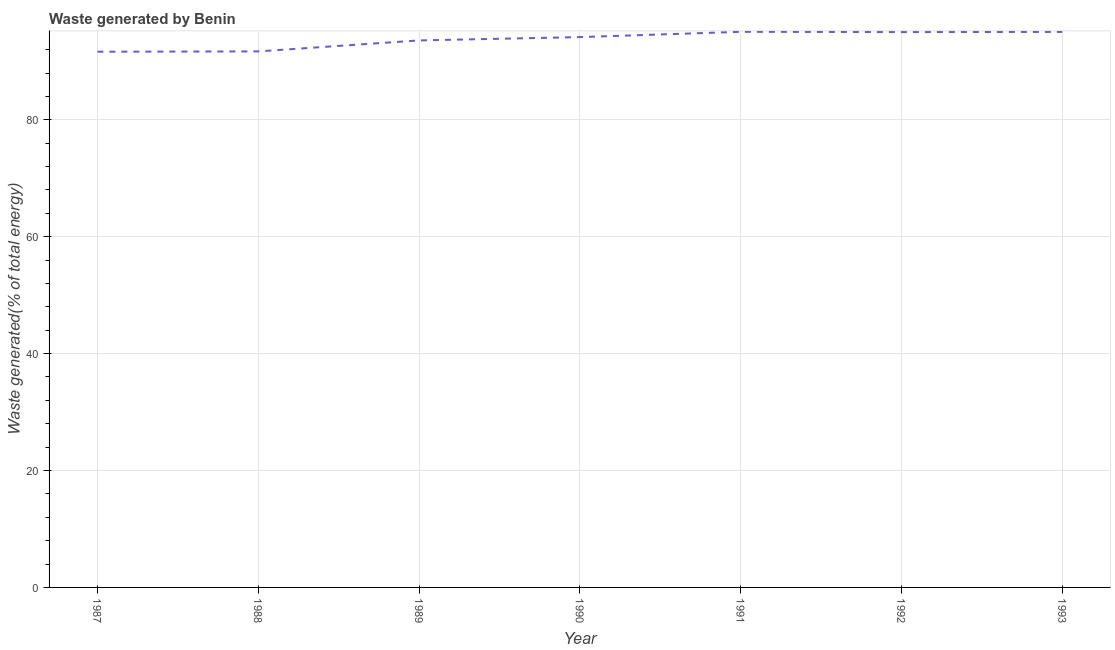What is the amount of waste generated in 1993?
Your response must be concise. 95.03. Across all years, what is the maximum amount of waste generated?
Provide a succinct answer. 95.05. Across all years, what is the minimum amount of waste generated?
Your answer should be very brief. 91.64. In which year was the amount of waste generated maximum?
Give a very brief answer. 1991. In which year was the amount of waste generated minimum?
Your answer should be compact. 1987. What is the sum of the amount of waste generated?
Make the answer very short. 656.15. What is the difference between the amount of waste generated in 1988 and 1990?
Keep it short and to the point. -2.45. What is the average amount of waste generated per year?
Provide a succinct answer. 93.74. What is the median amount of waste generated?
Ensure brevity in your answer.  94.15. Do a majority of the years between 1991 and 1988 (inclusive) have amount of waste generated greater than 24 %?
Provide a short and direct response. Yes. What is the ratio of the amount of waste generated in 1989 to that in 1993?
Give a very brief answer. 0.98. Is the amount of waste generated in 1988 less than that in 1989?
Ensure brevity in your answer.  Yes. Is the difference between the amount of waste generated in 1987 and 1992 greater than the difference between any two years?
Your answer should be very brief. No. What is the difference between the highest and the second highest amount of waste generated?
Offer a very short reply. 0.02. Is the sum of the amount of waste generated in 1990 and 1992 greater than the maximum amount of waste generated across all years?
Ensure brevity in your answer.  Yes. What is the difference between the highest and the lowest amount of waste generated?
Offer a terse response. 3.4. How many years are there in the graph?
Your answer should be compact. 7. What is the difference between two consecutive major ticks on the Y-axis?
Your answer should be compact. 20. What is the title of the graph?
Your answer should be compact. Waste generated by Benin. What is the label or title of the X-axis?
Offer a very short reply. Year. What is the label or title of the Y-axis?
Your answer should be very brief. Waste generated(% of total energy). What is the Waste generated(% of total energy) in 1987?
Provide a succinct answer. 91.64. What is the Waste generated(% of total energy) in 1988?
Provide a short and direct response. 91.7. What is the Waste generated(% of total energy) in 1989?
Give a very brief answer. 93.58. What is the Waste generated(% of total energy) in 1990?
Your response must be concise. 94.15. What is the Waste generated(% of total energy) of 1991?
Provide a succinct answer. 95.05. What is the Waste generated(% of total energy) in 1992?
Your answer should be very brief. 95. What is the Waste generated(% of total energy) in 1993?
Make the answer very short. 95.03. What is the difference between the Waste generated(% of total energy) in 1987 and 1988?
Keep it short and to the point. -0.05. What is the difference between the Waste generated(% of total energy) in 1987 and 1989?
Offer a terse response. -1.93. What is the difference between the Waste generated(% of total energy) in 1987 and 1990?
Offer a very short reply. -2.5. What is the difference between the Waste generated(% of total energy) in 1987 and 1991?
Offer a very short reply. -3.4. What is the difference between the Waste generated(% of total energy) in 1987 and 1992?
Keep it short and to the point. -3.36. What is the difference between the Waste generated(% of total energy) in 1987 and 1993?
Keep it short and to the point. -3.39. What is the difference between the Waste generated(% of total energy) in 1988 and 1989?
Your response must be concise. -1.88. What is the difference between the Waste generated(% of total energy) in 1988 and 1990?
Ensure brevity in your answer.  -2.45. What is the difference between the Waste generated(% of total energy) in 1988 and 1991?
Offer a very short reply. -3.35. What is the difference between the Waste generated(% of total energy) in 1988 and 1992?
Offer a very short reply. -3.31. What is the difference between the Waste generated(% of total energy) in 1988 and 1993?
Make the answer very short. -3.33. What is the difference between the Waste generated(% of total energy) in 1989 and 1990?
Offer a terse response. -0.57. What is the difference between the Waste generated(% of total energy) in 1989 and 1991?
Keep it short and to the point. -1.47. What is the difference between the Waste generated(% of total energy) in 1989 and 1992?
Give a very brief answer. -1.43. What is the difference between the Waste generated(% of total energy) in 1989 and 1993?
Your answer should be very brief. -1.46. What is the difference between the Waste generated(% of total energy) in 1990 and 1991?
Your response must be concise. -0.9. What is the difference between the Waste generated(% of total energy) in 1990 and 1992?
Give a very brief answer. -0.86. What is the difference between the Waste generated(% of total energy) in 1990 and 1993?
Your response must be concise. -0.89. What is the difference between the Waste generated(% of total energy) in 1991 and 1992?
Ensure brevity in your answer.  0.05. What is the difference between the Waste generated(% of total energy) in 1991 and 1993?
Keep it short and to the point. 0.02. What is the difference between the Waste generated(% of total energy) in 1992 and 1993?
Your answer should be very brief. -0.03. What is the ratio of the Waste generated(% of total energy) in 1987 to that in 1988?
Your answer should be very brief. 1. What is the ratio of the Waste generated(% of total energy) in 1987 to that in 1990?
Offer a terse response. 0.97. What is the ratio of the Waste generated(% of total energy) in 1987 to that in 1991?
Give a very brief answer. 0.96. What is the ratio of the Waste generated(% of total energy) in 1987 to that in 1993?
Provide a succinct answer. 0.96. What is the ratio of the Waste generated(% of total energy) in 1988 to that in 1989?
Make the answer very short. 0.98. What is the ratio of the Waste generated(% of total energy) in 1988 to that in 1991?
Your answer should be very brief. 0.96. What is the ratio of the Waste generated(% of total energy) in 1989 to that in 1991?
Make the answer very short. 0.98. What is the ratio of the Waste generated(% of total energy) in 1990 to that in 1991?
Keep it short and to the point. 0.99. What is the ratio of the Waste generated(% of total energy) in 1990 to that in 1992?
Provide a short and direct response. 0.99. 